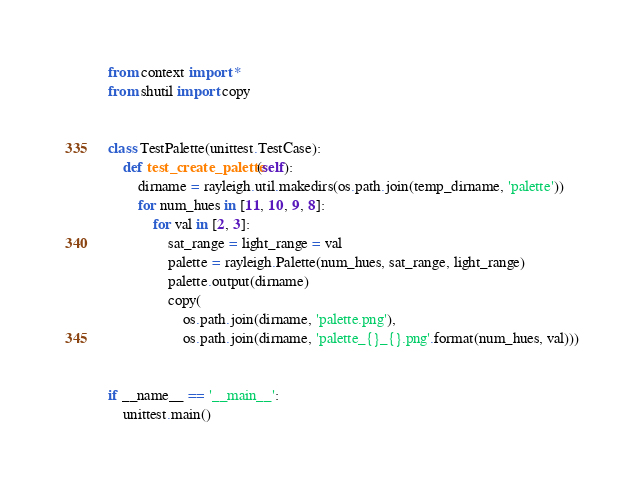Convert code to text. <code><loc_0><loc_0><loc_500><loc_500><_Python_>from context import *
from shutil import copy


class TestPalette(unittest.TestCase):
    def test_create_palette(self):
        dirname = rayleigh.util.makedirs(os.path.join(temp_dirname, 'palette'))
        for num_hues in [11, 10, 9, 8]:
            for val in [2, 3]:
                sat_range = light_range = val
                palette = rayleigh.Palette(num_hues, sat_range, light_range)
                palette.output(dirname)
                copy(
                    os.path.join(dirname, 'palette.png'),
                    os.path.join(dirname, 'palette_{}_{}.png'.format(num_hues, val)))


if __name__ == '__main__':
    unittest.main()
</code> 